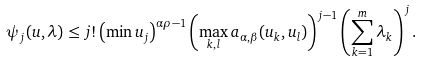<formula> <loc_0><loc_0><loc_500><loc_500>\psi _ { j } ( u , \lambda ) \leq j ! \left ( \min u _ { j } \right ) ^ { \alpha \rho - 1 } \left ( \max _ { k , l } a _ { \alpha , \beta } ( u _ { k } , u _ { l } ) \right ) ^ { j - 1 } \left ( \sum _ { k = 1 } ^ { m } \lambda _ { k } \right ) ^ { j } .</formula> 